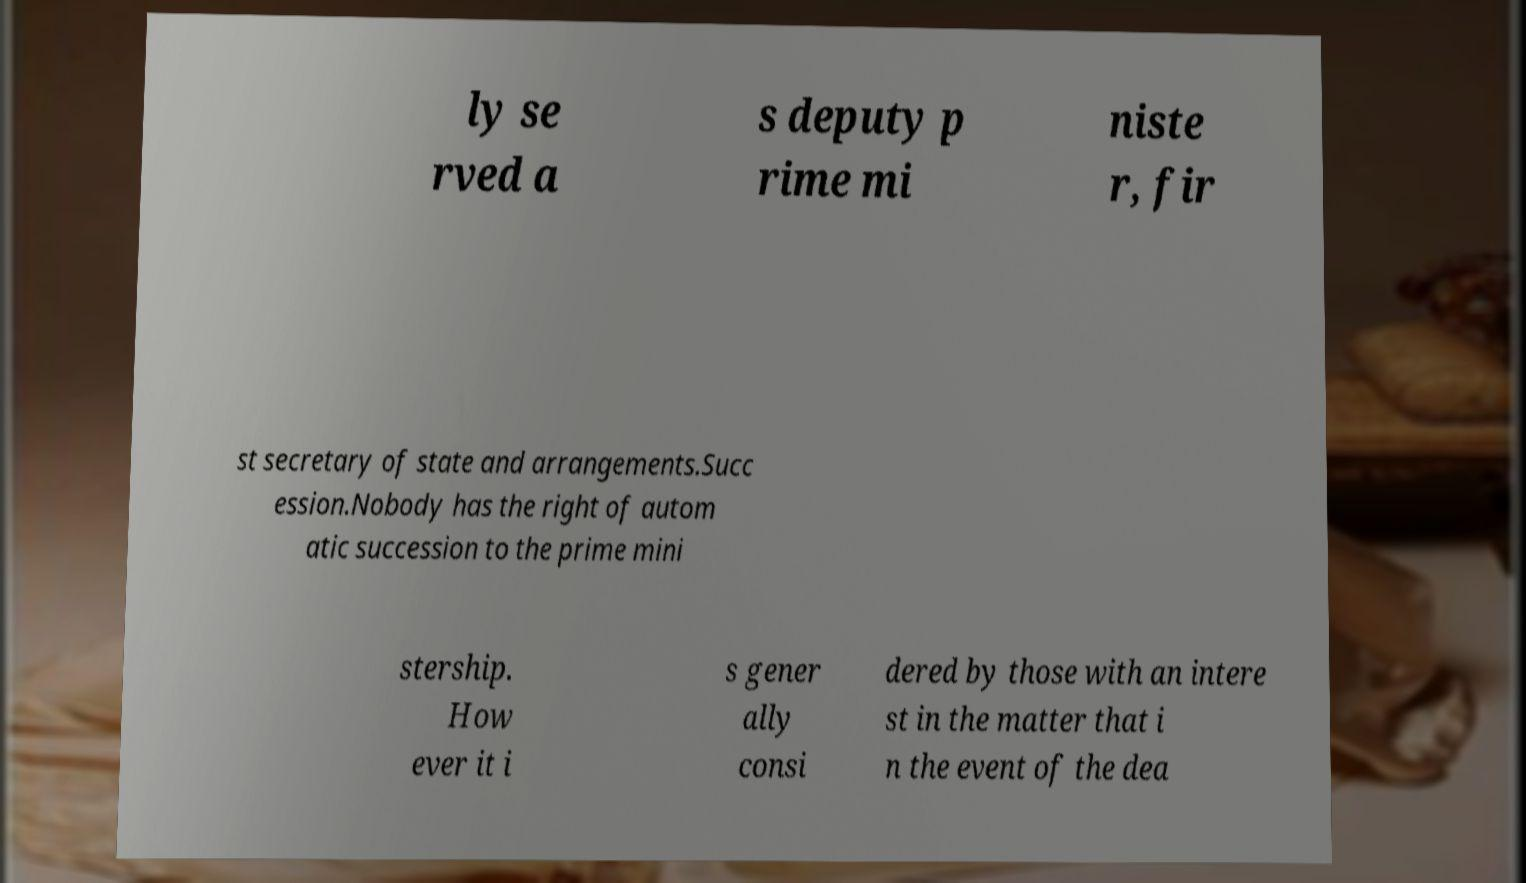What messages or text are displayed in this image? I need them in a readable, typed format. ly se rved a s deputy p rime mi niste r, fir st secretary of state and arrangements.Succ ession.Nobody has the right of autom atic succession to the prime mini stership. How ever it i s gener ally consi dered by those with an intere st in the matter that i n the event of the dea 